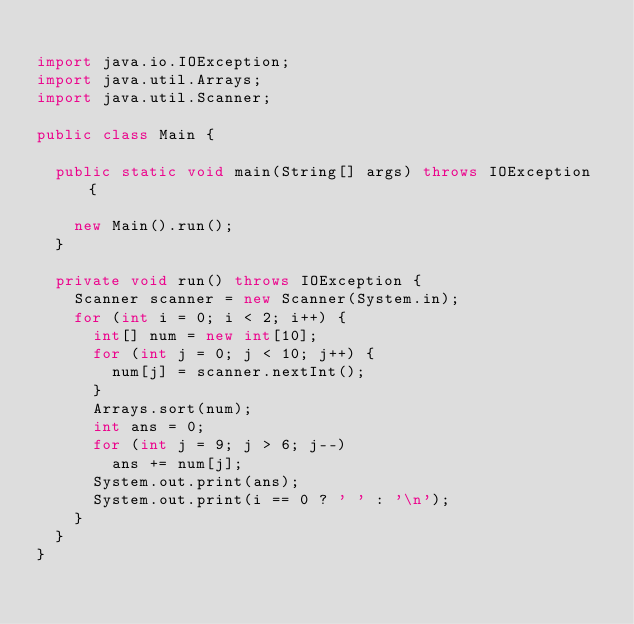Convert code to text. <code><loc_0><loc_0><loc_500><loc_500><_Java_>
import java.io.IOException;
import java.util.Arrays;
import java.util.Scanner;

public class Main {

	public static void main(String[] args) throws IOException {

		new Main().run();
	}

	private void run() throws IOException {
		Scanner scanner = new Scanner(System.in);
		for (int i = 0; i < 2; i++) {
			int[] num = new int[10];
			for (int j = 0; j < 10; j++) {
				num[j] = scanner.nextInt();
			}
			Arrays.sort(num);
			int ans = 0;
			for (int j = 9; j > 6; j--)
				ans += num[j];
			System.out.print(ans);
			System.out.print(i == 0 ? ' ' : '\n');
		}
	}
}</code> 